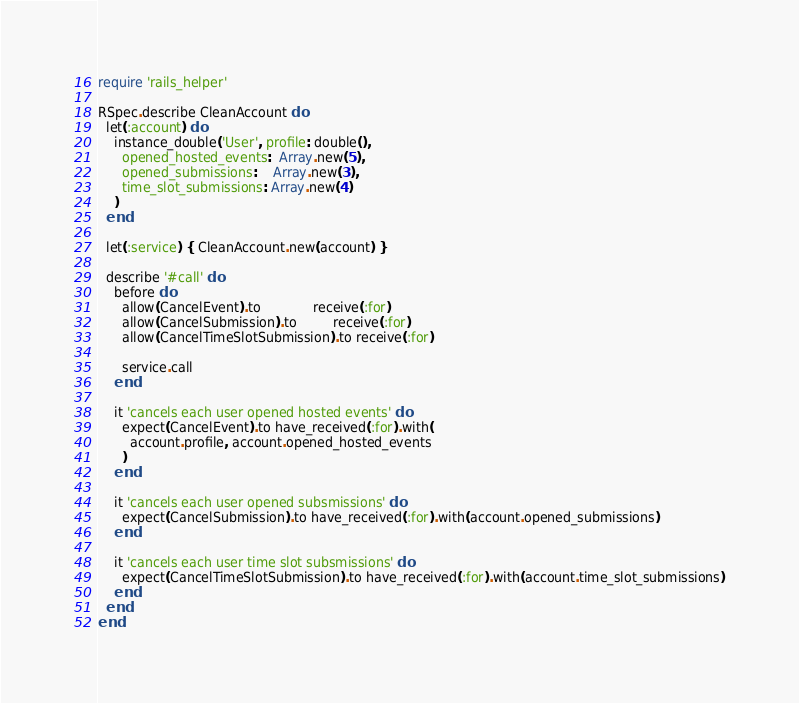<code> <loc_0><loc_0><loc_500><loc_500><_Ruby_>require 'rails_helper'

RSpec.describe CleanAccount do
  let(:account) do
    instance_double('User', profile: double(),
      opened_hosted_events:  Array.new(5),
      opened_submissions:    Array.new(3),
      time_slot_submissions: Array.new(4)
    )
  end

  let(:service) { CleanAccount.new(account) }

  describe '#call' do
    before do
      allow(CancelEvent).to             receive(:for)
      allow(CancelSubmission).to         receive(:for)
      allow(CancelTimeSlotSubmission).to receive(:for)

      service.call
    end

    it 'cancels each user opened hosted events' do
      expect(CancelEvent).to have_received(:for).with(
        account.profile, account.opened_hosted_events
      )
    end

    it 'cancels each user opened subsmissions' do
      expect(CancelSubmission).to have_received(:for).with(account.opened_submissions)
    end

    it 'cancels each user time slot subsmissions' do
      expect(CancelTimeSlotSubmission).to have_received(:for).with(account.time_slot_submissions)
    end
  end
end
</code> 